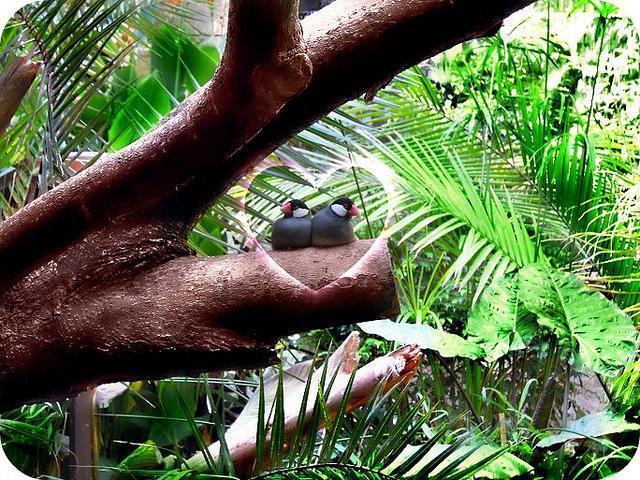How many giraffes are there?
Give a very brief answer. 0. 